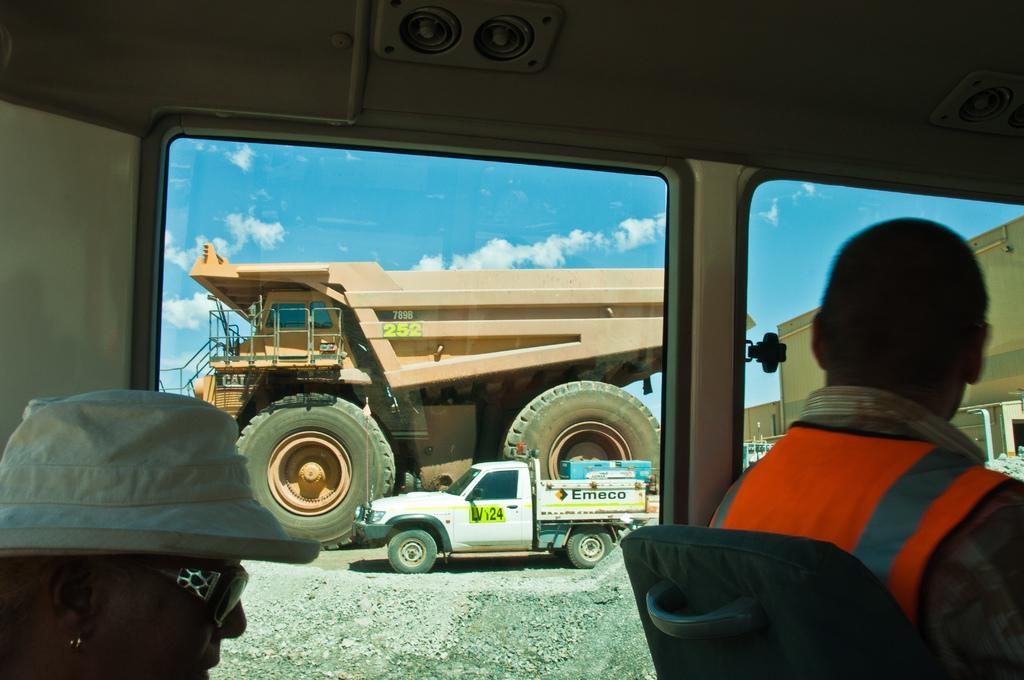Can you describe this image briefly? In this image in the center there are persons and there is a window. Behind the window there are vehicles. On the right side there are containers and the sky is cloudy. In the front on the right side there is a person sitting. 